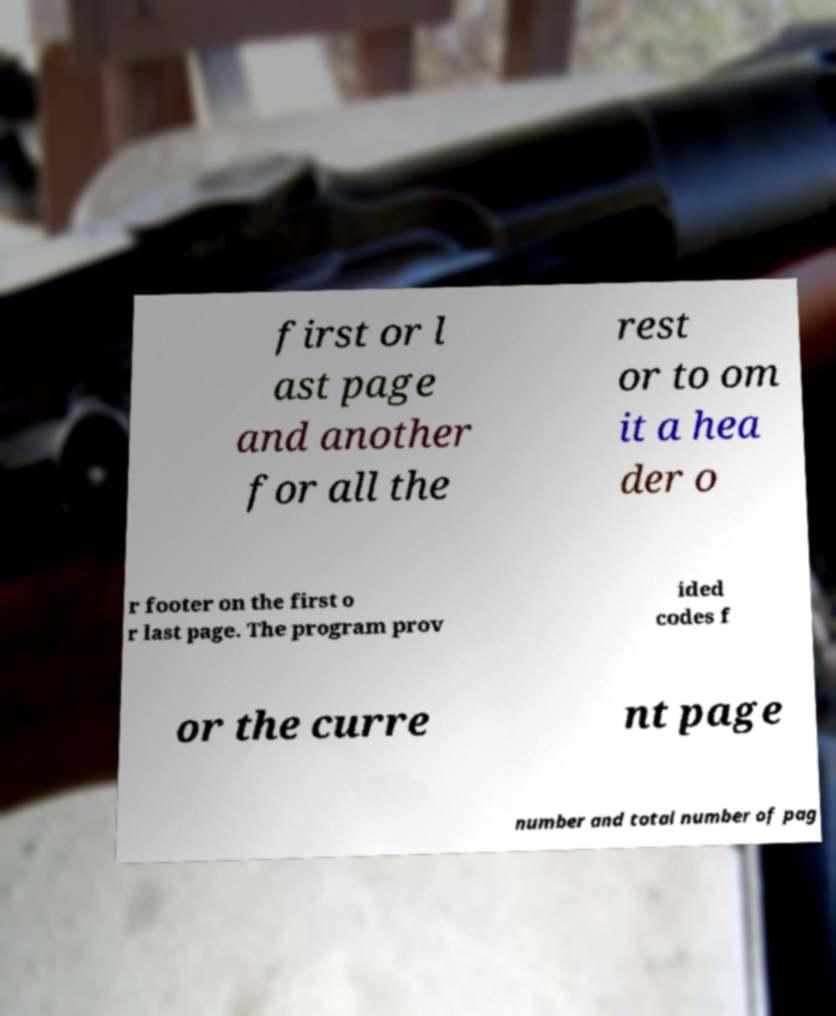Could you extract and type out the text from this image? first or l ast page and another for all the rest or to om it a hea der o r footer on the first o r last page. The program prov ided codes f or the curre nt page number and total number of pag 